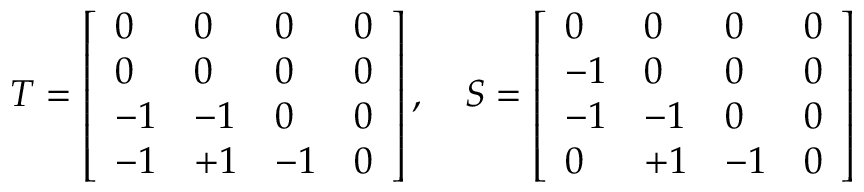<formula> <loc_0><loc_0><loc_500><loc_500>T = \left [ \begin{array} { l l l l } { 0 } & { 0 } & { 0 } & { 0 } \\ { 0 } & { 0 } & { 0 } & { 0 } \\ { - 1 } & { - 1 } & { 0 } & { 0 } \\ { - 1 } & { + 1 } & { - 1 } & { 0 } \end{array} \right ] , \quad S = \left [ \begin{array} { l l l l } { 0 } & { 0 } & { 0 } & { 0 } \\ { - 1 } & { 0 } & { 0 } & { 0 } \\ { - 1 } & { - 1 } & { 0 } & { 0 } \\ { 0 } & { + 1 } & { - 1 } & { 0 } \end{array} \right ]</formula> 